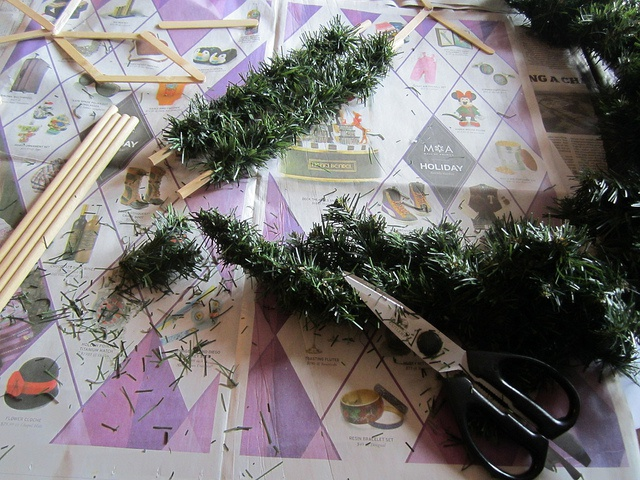Describe the objects in this image and their specific colors. I can see scissors in darkgray, black, and gray tones in this image. 